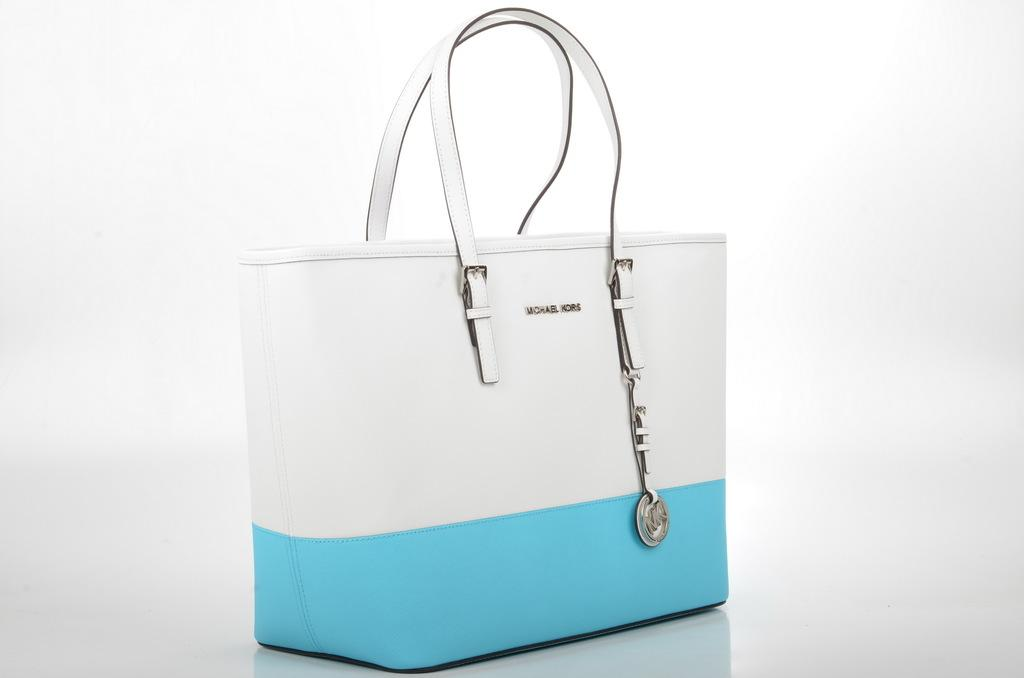What colors are used for the handbag in the image? The handbag is white and blue in color. Can you see any bones inside the handbag in the image? There is no mention of bones in the image, and therefore it cannot be determined if any are present. Is there a tiger visible inside the handbag in the image? There is no mention of a tiger in the image, and therefore it cannot be determined if one is present. 